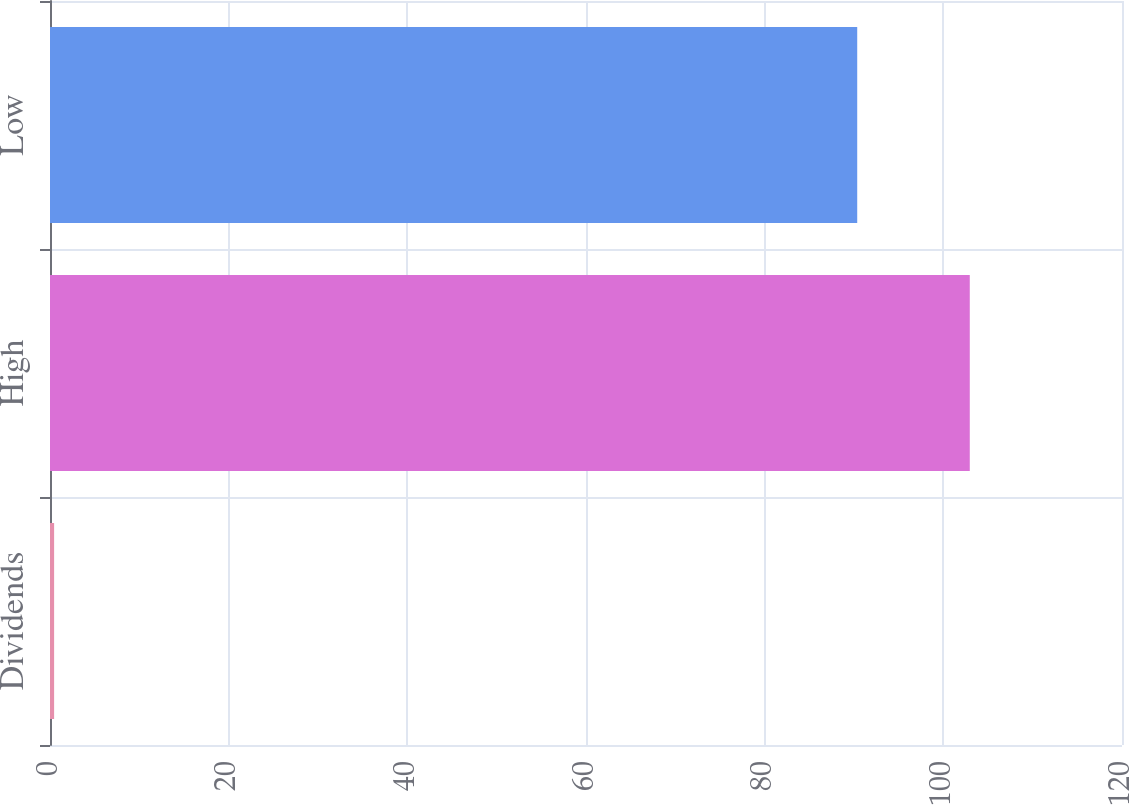<chart> <loc_0><loc_0><loc_500><loc_500><bar_chart><fcel>Dividends<fcel>High<fcel>Low<nl><fcel>0.46<fcel>102.96<fcel>90.36<nl></chart> 